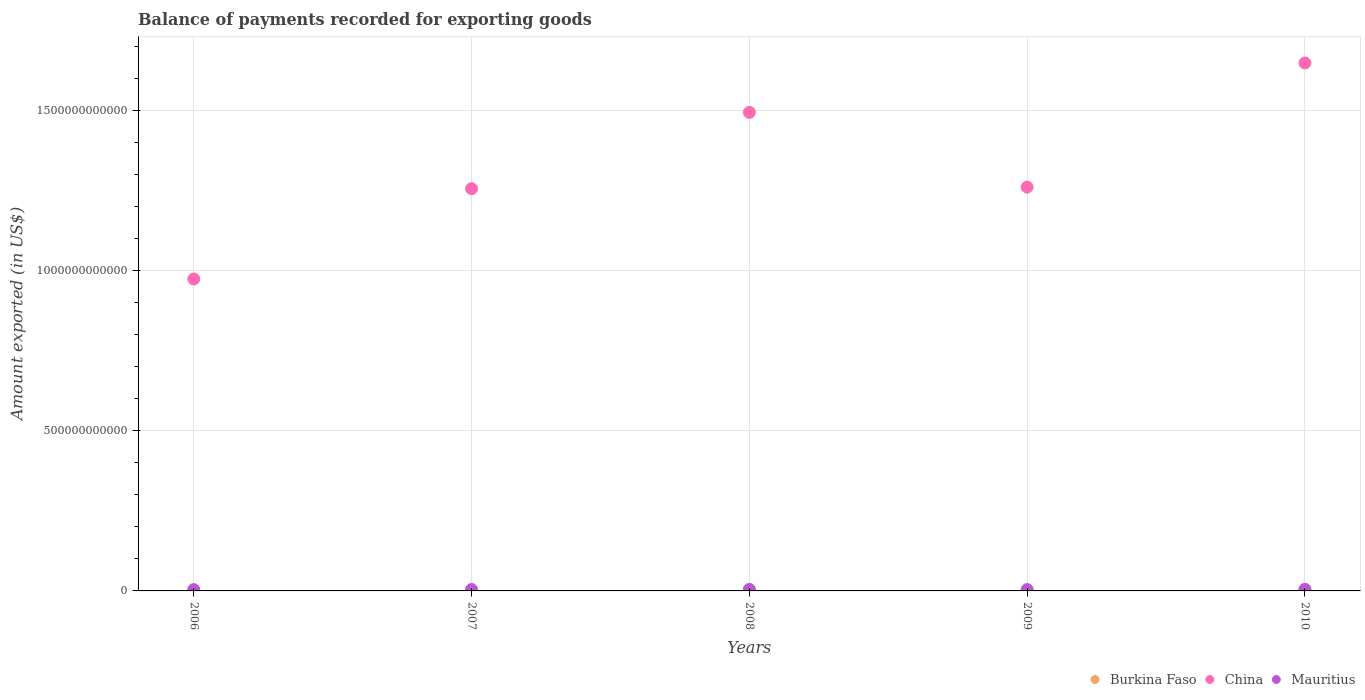What is the amount exported in Mauritius in 2006?
Give a very brief answer. 4.00e+09. Across all years, what is the maximum amount exported in China?
Offer a very short reply. 1.65e+12. Across all years, what is the minimum amount exported in Burkina Faso?
Keep it short and to the point. 6.68e+08. In which year was the amount exported in China maximum?
Give a very brief answer. 2010. In which year was the amount exported in Burkina Faso minimum?
Your answer should be very brief. 2006. What is the total amount exported in Burkina Faso in the graph?
Your answer should be very brief. 5.33e+09. What is the difference between the amount exported in China in 2007 and that in 2010?
Offer a very short reply. -3.92e+11. What is the difference between the amount exported in Burkina Faso in 2006 and the amount exported in Mauritius in 2008?
Your response must be concise. -4.26e+09. What is the average amount exported in China per year?
Offer a very short reply. 1.33e+12. In the year 2008, what is the difference between the amount exported in Mauritius and amount exported in China?
Your answer should be compact. -1.49e+12. In how many years, is the amount exported in China greater than 700000000000 US$?
Provide a short and direct response. 5. What is the ratio of the amount exported in Mauritius in 2007 to that in 2010?
Make the answer very short. 0.9. Is the amount exported in Burkina Faso in 2009 less than that in 2010?
Your response must be concise. Yes. What is the difference between the highest and the second highest amount exported in Mauritius?
Give a very brief answer. 2.88e+07. What is the difference between the highest and the lowest amount exported in Mauritius?
Your answer should be compact. 9.56e+08. In how many years, is the amount exported in China greater than the average amount exported in China taken over all years?
Offer a very short reply. 2. Is the sum of the amount exported in Mauritius in 2006 and 2009 greater than the maximum amount exported in China across all years?
Provide a succinct answer. No. Is the amount exported in China strictly less than the amount exported in Burkina Faso over the years?
Your response must be concise. No. How many dotlines are there?
Give a very brief answer. 3. How many years are there in the graph?
Make the answer very short. 5. What is the difference between two consecutive major ticks on the Y-axis?
Offer a very short reply. 5.00e+11. Are the values on the major ticks of Y-axis written in scientific E-notation?
Provide a short and direct response. No. Does the graph contain any zero values?
Your answer should be very brief. No. How many legend labels are there?
Keep it short and to the point. 3. What is the title of the graph?
Your response must be concise. Balance of payments recorded for exporting goods. What is the label or title of the Y-axis?
Make the answer very short. Amount exported (in US$). What is the Amount exported (in US$) in Burkina Faso in 2006?
Keep it short and to the point. 6.68e+08. What is the Amount exported (in US$) of China in 2006?
Provide a succinct answer. 9.73e+11. What is the Amount exported (in US$) of Mauritius in 2006?
Make the answer very short. 4.00e+09. What is the Amount exported (in US$) in Burkina Faso in 2007?
Your answer should be compact. 7.41e+08. What is the Amount exported (in US$) in China in 2007?
Offer a terse response. 1.26e+12. What is the Amount exported (in US$) of Mauritius in 2007?
Your response must be concise. 4.44e+09. What is the Amount exported (in US$) in Burkina Faso in 2008?
Your answer should be compact. 9.84e+08. What is the Amount exported (in US$) in China in 2008?
Keep it short and to the point. 1.49e+12. What is the Amount exported (in US$) of Mauritius in 2008?
Provide a short and direct response. 4.93e+09. What is the Amount exported (in US$) in Burkina Faso in 2009?
Provide a succinct answer. 1.05e+09. What is the Amount exported (in US$) of China in 2009?
Keep it short and to the point. 1.26e+12. What is the Amount exported (in US$) in Mauritius in 2009?
Offer a very short reply. 4.18e+09. What is the Amount exported (in US$) of Burkina Faso in 2010?
Keep it short and to the point. 1.89e+09. What is the Amount exported (in US$) in China in 2010?
Offer a very short reply. 1.65e+12. What is the Amount exported (in US$) in Mauritius in 2010?
Provide a short and direct response. 4.96e+09. Across all years, what is the maximum Amount exported (in US$) in Burkina Faso?
Provide a succinct answer. 1.89e+09. Across all years, what is the maximum Amount exported (in US$) of China?
Keep it short and to the point. 1.65e+12. Across all years, what is the maximum Amount exported (in US$) in Mauritius?
Provide a succinct answer. 4.96e+09. Across all years, what is the minimum Amount exported (in US$) in Burkina Faso?
Provide a succinct answer. 6.68e+08. Across all years, what is the minimum Amount exported (in US$) of China?
Make the answer very short. 9.73e+11. Across all years, what is the minimum Amount exported (in US$) of Mauritius?
Provide a short and direct response. 4.00e+09. What is the total Amount exported (in US$) in Burkina Faso in the graph?
Provide a short and direct response. 5.33e+09. What is the total Amount exported (in US$) of China in the graph?
Your answer should be compact. 6.63e+12. What is the total Amount exported (in US$) in Mauritius in the graph?
Provide a short and direct response. 2.25e+1. What is the difference between the Amount exported (in US$) of Burkina Faso in 2006 and that in 2007?
Make the answer very short. -7.29e+07. What is the difference between the Amount exported (in US$) in China in 2006 and that in 2007?
Your answer should be very brief. -2.82e+11. What is the difference between the Amount exported (in US$) of Mauritius in 2006 and that in 2007?
Offer a very short reply. -4.43e+08. What is the difference between the Amount exported (in US$) in Burkina Faso in 2006 and that in 2008?
Your response must be concise. -3.16e+08. What is the difference between the Amount exported (in US$) of China in 2006 and that in 2008?
Ensure brevity in your answer.  -5.20e+11. What is the difference between the Amount exported (in US$) of Mauritius in 2006 and that in 2008?
Offer a very short reply. -9.28e+08. What is the difference between the Amount exported (in US$) of Burkina Faso in 2006 and that in 2009?
Your answer should be compact. -3.85e+08. What is the difference between the Amount exported (in US$) in China in 2006 and that in 2009?
Your response must be concise. -2.87e+11. What is the difference between the Amount exported (in US$) of Mauritius in 2006 and that in 2009?
Give a very brief answer. -1.77e+08. What is the difference between the Amount exported (in US$) of Burkina Faso in 2006 and that in 2010?
Your response must be concise. -1.22e+09. What is the difference between the Amount exported (in US$) in China in 2006 and that in 2010?
Provide a short and direct response. -6.74e+11. What is the difference between the Amount exported (in US$) in Mauritius in 2006 and that in 2010?
Ensure brevity in your answer.  -9.56e+08. What is the difference between the Amount exported (in US$) in Burkina Faso in 2007 and that in 2008?
Give a very brief answer. -2.43e+08. What is the difference between the Amount exported (in US$) in China in 2007 and that in 2008?
Your response must be concise. -2.38e+11. What is the difference between the Amount exported (in US$) in Mauritius in 2007 and that in 2008?
Give a very brief answer. -4.85e+08. What is the difference between the Amount exported (in US$) in Burkina Faso in 2007 and that in 2009?
Offer a very short reply. -3.12e+08. What is the difference between the Amount exported (in US$) in China in 2007 and that in 2009?
Ensure brevity in your answer.  -4.97e+09. What is the difference between the Amount exported (in US$) of Mauritius in 2007 and that in 2009?
Provide a short and direct response. 2.66e+08. What is the difference between the Amount exported (in US$) of Burkina Faso in 2007 and that in 2010?
Make the answer very short. -1.15e+09. What is the difference between the Amount exported (in US$) in China in 2007 and that in 2010?
Provide a short and direct response. -3.92e+11. What is the difference between the Amount exported (in US$) of Mauritius in 2007 and that in 2010?
Keep it short and to the point. -5.14e+08. What is the difference between the Amount exported (in US$) in Burkina Faso in 2008 and that in 2009?
Provide a succinct answer. -6.92e+07. What is the difference between the Amount exported (in US$) in China in 2008 and that in 2009?
Give a very brief answer. 2.33e+11. What is the difference between the Amount exported (in US$) of Mauritius in 2008 and that in 2009?
Your response must be concise. 7.50e+08. What is the difference between the Amount exported (in US$) of Burkina Faso in 2008 and that in 2010?
Ensure brevity in your answer.  -9.05e+08. What is the difference between the Amount exported (in US$) of China in 2008 and that in 2010?
Provide a short and direct response. -1.54e+11. What is the difference between the Amount exported (in US$) of Mauritius in 2008 and that in 2010?
Your answer should be very brief. -2.88e+07. What is the difference between the Amount exported (in US$) of Burkina Faso in 2009 and that in 2010?
Your answer should be compact. -8.36e+08. What is the difference between the Amount exported (in US$) of China in 2009 and that in 2010?
Ensure brevity in your answer.  -3.87e+11. What is the difference between the Amount exported (in US$) in Mauritius in 2009 and that in 2010?
Your answer should be compact. -7.79e+08. What is the difference between the Amount exported (in US$) of Burkina Faso in 2006 and the Amount exported (in US$) of China in 2007?
Keep it short and to the point. -1.25e+12. What is the difference between the Amount exported (in US$) of Burkina Faso in 2006 and the Amount exported (in US$) of Mauritius in 2007?
Ensure brevity in your answer.  -3.78e+09. What is the difference between the Amount exported (in US$) of China in 2006 and the Amount exported (in US$) of Mauritius in 2007?
Offer a very short reply. 9.69e+11. What is the difference between the Amount exported (in US$) of Burkina Faso in 2006 and the Amount exported (in US$) of China in 2008?
Your answer should be very brief. -1.49e+12. What is the difference between the Amount exported (in US$) in Burkina Faso in 2006 and the Amount exported (in US$) in Mauritius in 2008?
Give a very brief answer. -4.26e+09. What is the difference between the Amount exported (in US$) in China in 2006 and the Amount exported (in US$) in Mauritius in 2008?
Your answer should be very brief. 9.69e+11. What is the difference between the Amount exported (in US$) in Burkina Faso in 2006 and the Amount exported (in US$) in China in 2009?
Your answer should be very brief. -1.26e+12. What is the difference between the Amount exported (in US$) of Burkina Faso in 2006 and the Amount exported (in US$) of Mauritius in 2009?
Make the answer very short. -3.51e+09. What is the difference between the Amount exported (in US$) in China in 2006 and the Amount exported (in US$) in Mauritius in 2009?
Keep it short and to the point. 9.69e+11. What is the difference between the Amount exported (in US$) of Burkina Faso in 2006 and the Amount exported (in US$) of China in 2010?
Provide a succinct answer. -1.65e+12. What is the difference between the Amount exported (in US$) of Burkina Faso in 2006 and the Amount exported (in US$) of Mauritius in 2010?
Give a very brief answer. -4.29e+09. What is the difference between the Amount exported (in US$) in China in 2006 and the Amount exported (in US$) in Mauritius in 2010?
Make the answer very short. 9.69e+11. What is the difference between the Amount exported (in US$) of Burkina Faso in 2007 and the Amount exported (in US$) of China in 2008?
Give a very brief answer. -1.49e+12. What is the difference between the Amount exported (in US$) in Burkina Faso in 2007 and the Amount exported (in US$) in Mauritius in 2008?
Your response must be concise. -4.19e+09. What is the difference between the Amount exported (in US$) of China in 2007 and the Amount exported (in US$) of Mauritius in 2008?
Your answer should be compact. 1.25e+12. What is the difference between the Amount exported (in US$) of Burkina Faso in 2007 and the Amount exported (in US$) of China in 2009?
Provide a succinct answer. -1.26e+12. What is the difference between the Amount exported (in US$) of Burkina Faso in 2007 and the Amount exported (in US$) of Mauritius in 2009?
Keep it short and to the point. -3.44e+09. What is the difference between the Amount exported (in US$) of China in 2007 and the Amount exported (in US$) of Mauritius in 2009?
Provide a succinct answer. 1.25e+12. What is the difference between the Amount exported (in US$) in Burkina Faso in 2007 and the Amount exported (in US$) in China in 2010?
Offer a terse response. -1.65e+12. What is the difference between the Amount exported (in US$) of Burkina Faso in 2007 and the Amount exported (in US$) of Mauritius in 2010?
Your answer should be compact. -4.22e+09. What is the difference between the Amount exported (in US$) in China in 2007 and the Amount exported (in US$) in Mauritius in 2010?
Offer a very short reply. 1.25e+12. What is the difference between the Amount exported (in US$) of Burkina Faso in 2008 and the Amount exported (in US$) of China in 2009?
Your answer should be very brief. -1.26e+12. What is the difference between the Amount exported (in US$) of Burkina Faso in 2008 and the Amount exported (in US$) of Mauritius in 2009?
Your response must be concise. -3.19e+09. What is the difference between the Amount exported (in US$) in China in 2008 and the Amount exported (in US$) in Mauritius in 2009?
Offer a very short reply. 1.49e+12. What is the difference between the Amount exported (in US$) of Burkina Faso in 2008 and the Amount exported (in US$) of China in 2010?
Your answer should be compact. -1.65e+12. What is the difference between the Amount exported (in US$) in Burkina Faso in 2008 and the Amount exported (in US$) in Mauritius in 2010?
Your answer should be compact. -3.97e+09. What is the difference between the Amount exported (in US$) in China in 2008 and the Amount exported (in US$) in Mauritius in 2010?
Provide a short and direct response. 1.49e+12. What is the difference between the Amount exported (in US$) in Burkina Faso in 2009 and the Amount exported (in US$) in China in 2010?
Provide a succinct answer. -1.65e+12. What is the difference between the Amount exported (in US$) of Burkina Faso in 2009 and the Amount exported (in US$) of Mauritius in 2010?
Ensure brevity in your answer.  -3.90e+09. What is the difference between the Amount exported (in US$) in China in 2009 and the Amount exported (in US$) in Mauritius in 2010?
Ensure brevity in your answer.  1.26e+12. What is the average Amount exported (in US$) in Burkina Faso per year?
Your response must be concise. 1.07e+09. What is the average Amount exported (in US$) of China per year?
Make the answer very short. 1.33e+12. What is the average Amount exported (in US$) in Mauritius per year?
Provide a succinct answer. 4.50e+09. In the year 2006, what is the difference between the Amount exported (in US$) of Burkina Faso and Amount exported (in US$) of China?
Ensure brevity in your answer.  -9.73e+11. In the year 2006, what is the difference between the Amount exported (in US$) in Burkina Faso and Amount exported (in US$) in Mauritius?
Your response must be concise. -3.33e+09. In the year 2006, what is the difference between the Amount exported (in US$) in China and Amount exported (in US$) in Mauritius?
Give a very brief answer. 9.69e+11. In the year 2007, what is the difference between the Amount exported (in US$) of Burkina Faso and Amount exported (in US$) of China?
Make the answer very short. -1.25e+12. In the year 2007, what is the difference between the Amount exported (in US$) of Burkina Faso and Amount exported (in US$) of Mauritius?
Offer a very short reply. -3.70e+09. In the year 2007, what is the difference between the Amount exported (in US$) in China and Amount exported (in US$) in Mauritius?
Make the answer very short. 1.25e+12. In the year 2008, what is the difference between the Amount exported (in US$) in Burkina Faso and Amount exported (in US$) in China?
Your response must be concise. -1.49e+12. In the year 2008, what is the difference between the Amount exported (in US$) in Burkina Faso and Amount exported (in US$) in Mauritius?
Your response must be concise. -3.94e+09. In the year 2008, what is the difference between the Amount exported (in US$) of China and Amount exported (in US$) of Mauritius?
Keep it short and to the point. 1.49e+12. In the year 2009, what is the difference between the Amount exported (in US$) of Burkina Faso and Amount exported (in US$) of China?
Ensure brevity in your answer.  -1.26e+12. In the year 2009, what is the difference between the Amount exported (in US$) in Burkina Faso and Amount exported (in US$) in Mauritius?
Provide a succinct answer. -3.12e+09. In the year 2009, what is the difference between the Amount exported (in US$) of China and Amount exported (in US$) of Mauritius?
Provide a succinct answer. 1.26e+12. In the year 2010, what is the difference between the Amount exported (in US$) of Burkina Faso and Amount exported (in US$) of China?
Keep it short and to the point. -1.65e+12. In the year 2010, what is the difference between the Amount exported (in US$) in Burkina Faso and Amount exported (in US$) in Mauritius?
Provide a succinct answer. -3.07e+09. In the year 2010, what is the difference between the Amount exported (in US$) of China and Amount exported (in US$) of Mauritius?
Provide a short and direct response. 1.64e+12. What is the ratio of the Amount exported (in US$) in Burkina Faso in 2006 to that in 2007?
Offer a terse response. 0.9. What is the ratio of the Amount exported (in US$) in China in 2006 to that in 2007?
Your response must be concise. 0.78. What is the ratio of the Amount exported (in US$) of Mauritius in 2006 to that in 2007?
Provide a succinct answer. 0.9. What is the ratio of the Amount exported (in US$) in Burkina Faso in 2006 to that in 2008?
Keep it short and to the point. 0.68. What is the ratio of the Amount exported (in US$) in China in 2006 to that in 2008?
Keep it short and to the point. 0.65. What is the ratio of the Amount exported (in US$) in Mauritius in 2006 to that in 2008?
Your response must be concise. 0.81. What is the ratio of the Amount exported (in US$) of Burkina Faso in 2006 to that in 2009?
Make the answer very short. 0.63. What is the ratio of the Amount exported (in US$) in China in 2006 to that in 2009?
Offer a terse response. 0.77. What is the ratio of the Amount exported (in US$) of Mauritius in 2006 to that in 2009?
Your answer should be compact. 0.96. What is the ratio of the Amount exported (in US$) of Burkina Faso in 2006 to that in 2010?
Keep it short and to the point. 0.35. What is the ratio of the Amount exported (in US$) in China in 2006 to that in 2010?
Give a very brief answer. 0.59. What is the ratio of the Amount exported (in US$) in Mauritius in 2006 to that in 2010?
Offer a very short reply. 0.81. What is the ratio of the Amount exported (in US$) in Burkina Faso in 2007 to that in 2008?
Make the answer very short. 0.75. What is the ratio of the Amount exported (in US$) in China in 2007 to that in 2008?
Offer a terse response. 0.84. What is the ratio of the Amount exported (in US$) of Mauritius in 2007 to that in 2008?
Provide a short and direct response. 0.9. What is the ratio of the Amount exported (in US$) in Burkina Faso in 2007 to that in 2009?
Make the answer very short. 0.7. What is the ratio of the Amount exported (in US$) in China in 2007 to that in 2009?
Ensure brevity in your answer.  1. What is the ratio of the Amount exported (in US$) in Mauritius in 2007 to that in 2009?
Offer a terse response. 1.06. What is the ratio of the Amount exported (in US$) of Burkina Faso in 2007 to that in 2010?
Provide a succinct answer. 0.39. What is the ratio of the Amount exported (in US$) in China in 2007 to that in 2010?
Offer a terse response. 0.76. What is the ratio of the Amount exported (in US$) in Mauritius in 2007 to that in 2010?
Your answer should be compact. 0.9. What is the ratio of the Amount exported (in US$) in Burkina Faso in 2008 to that in 2009?
Offer a very short reply. 0.93. What is the ratio of the Amount exported (in US$) of China in 2008 to that in 2009?
Provide a short and direct response. 1.19. What is the ratio of the Amount exported (in US$) of Mauritius in 2008 to that in 2009?
Offer a very short reply. 1.18. What is the ratio of the Amount exported (in US$) in Burkina Faso in 2008 to that in 2010?
Make the answer very short. 0.52. What is the ratio of the Amount exported (in US$) of China in 2008 to that in 2010?
Offer a very short reply. 0.91. What is the ratio of the Amount exported (in US$) in Burkina Faso in 2009 to that in 2010?
Offer a terse response. 0.56. What is the ratio of the Amount exported (in US$) of China in 2009 to that in 2010?
Your answer should be compact. 0.76. What is the ratio of the Amount exported (in US$) of Mauritius in 2009 to that in 2010?
Provide a succinct answer. 0.84. What is the difference between the highest and the second highest Amount exported (in US$) of Burkina Faso?
Keep it short and to the point. 8.36e+08. What is the difference between the highest and the second highest Amount exported (in US$) in China?
Offer a terse response. 1.54e+11. What is the difference between the highest and the second highest Amount exported (in US$) in Mauritius?
Offer a very short reply. 2.88e+07. What is the difference between the highest and the lowest Amount exported (in US$) in Burkina Faso?
Offer a terse response. 1.22e+09. What is the difference between the highest and the lowest Amount exported (in US$) of China?
Your answer should be very brief. 6.74e+11. What is the difference between the highest and the lowest Amount exported (in US$) of Mauritius?
Your answer should be compact. 9.56e+08. 